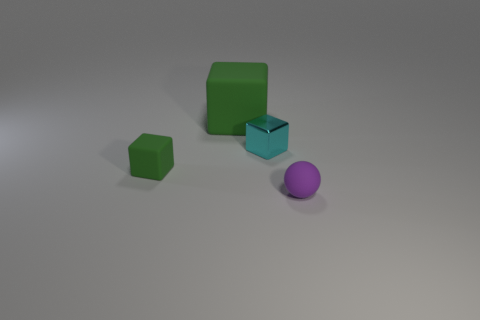Subtract all large rubber cubes. How many cubes are left? 2 Subtract all brown spheres. How many green blocks are left? 2 Subtract 1 balls. How many balls are left? 0 Subtract all cyan cubes. How many cubes are left? 2 Add 4 tiny matte balls. How many objects exist? 8 Add 3 things. How many things exist? 7 Subtract 0 cyan cylinders. How many objects are left? 4 Subtract all spheres. How many objects are left? 3 Subtract all blue blocks. Subtract all red spheres. How many blocks are left? 3 Subtract all big purple balls. Subtract all shiny blocks. How many objects are left? 3 